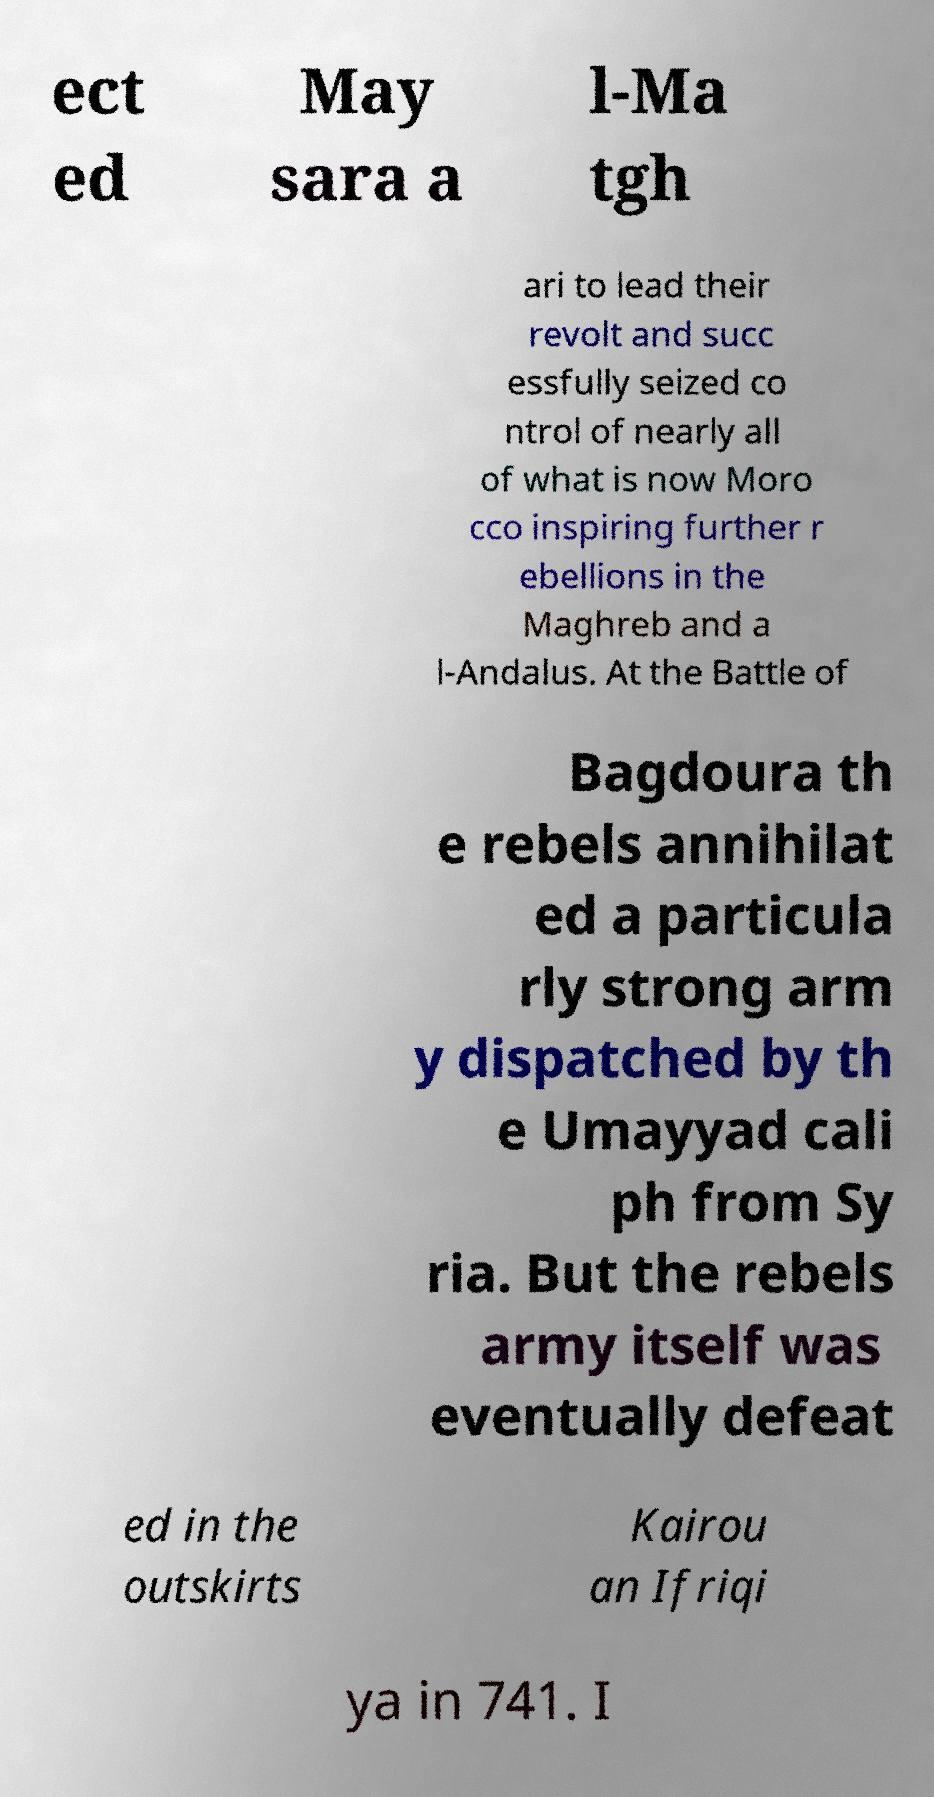Please read and relay the text visible in this image. What does it say? ect ed May sara a l-Ma tgh ari to lead their revolt and succ essfully seized co ntrol of nearly all of what is now Moro cco inspiring further r ebellions in the Maghreb and a l-Andalus. At the Battle of Bagdoura th e rebels annihilat ed a particula rly strong arm y dispatched by th e Umayyad cali ph from Sy ria. But the rebels army itself was eventually defeat ed in the outskirts Kairou an Ifriqi ya in 741. I 